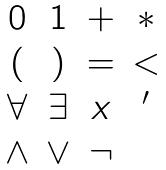Convert formula to latex. <formula><loc_0><loc_0><loc_500><loc_500>\begin{matrix} 0 & 1 & + & * \\ ( & ) & = & < \\ \forall & \exists & x & ^ { \prime } \\ \wedge & \vee & \neg \\ \end{matrix}</formula> 